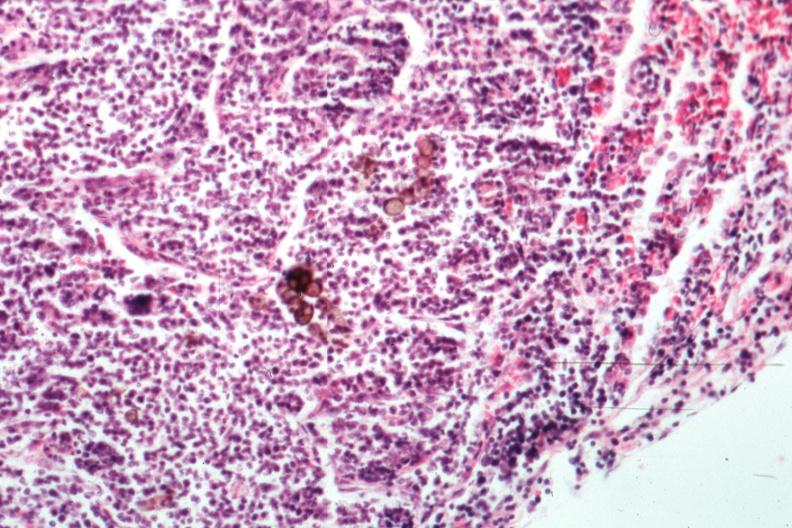what is present?
Answer the question using a single word or phrase. Chromoblastomycosis 